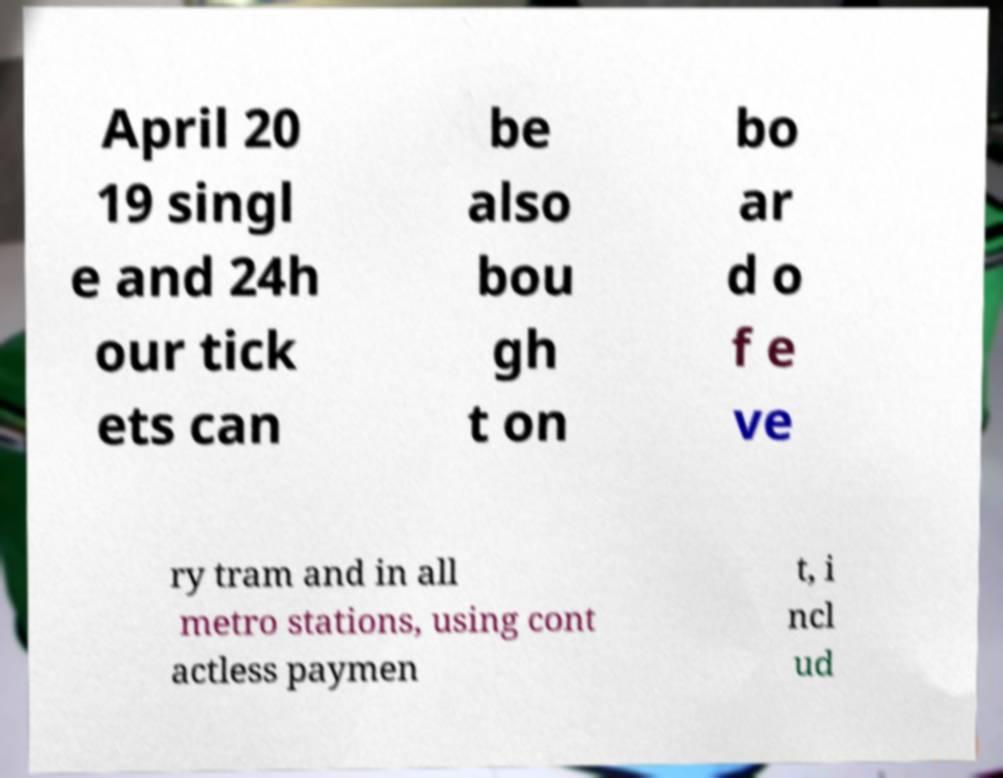What messages or text are displayed in this image? I need them in a readable, typed format. April 20 19 singl e and 24h our tick ets can be also bou gh t on bo ar d o f e ve ry tram and in all metro stations, using cont actless paymen t, i ncl ud 